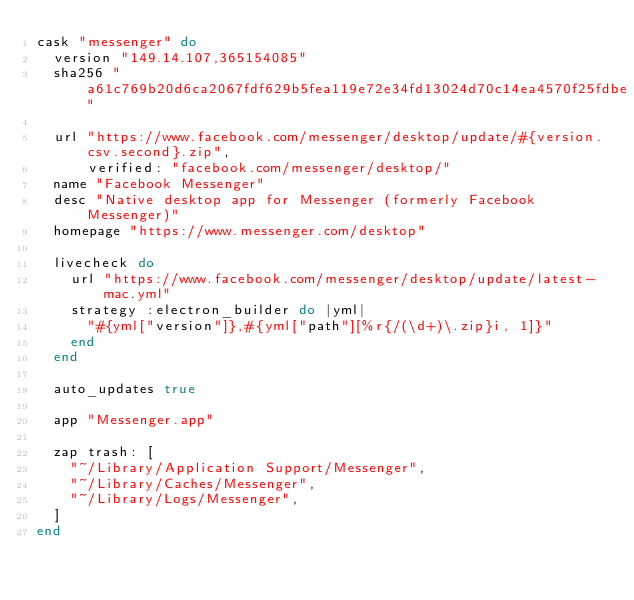<code> <loc_0><loc_0><loc_500><loc_500><_Ruby_>cask "messenger" do
  version "149.14.107,365154085"
  sha256 "a61c769b20d6ca2067fdf629b5fea119e72e34fd13024d70c14ea4570f25fdbe"

  url "https://www.facebook.com/messenger/desktop/update/#{version.csv.second}.zip",
      verified: "facebook.com/messenger/desktop/"
  name "Facebook Messenger"
  desc "Native desktop app for Messenger (formerly Facebook Messenger)"
  homepage "https://www.messenger.com/desktop"

  livecheck do
    url "https://www.facebook.com/messenger/desktop/update/latest-mac.yml"
    strategy :electron_builder do |yml|
      "#{yml["version"]},#{yml["path"][%r{/(\d+)\.zip}i, 1]}"
    end
  end

  auto_updates true

  app "Messenger.app"

  zap trash: [
    "~/Library/Application Support/Messenger",
    "~/Library/Caches/Messenger",
    "~/Library/Logs/Messenger",
  ]
end
</code> 